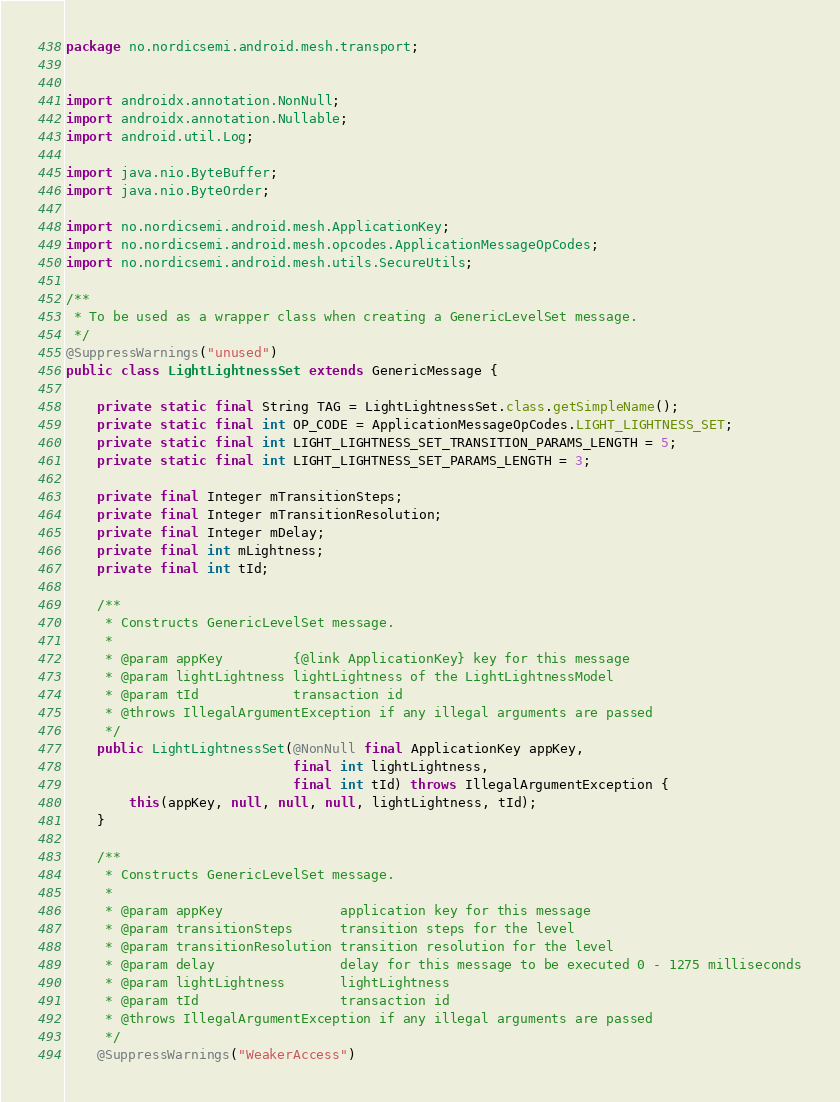<code> <loc_0><loc_0><loc_500><loc_500><_Java_>package no.nordicsemi.android.mesh.transport;


import androidx.annotation.NonNull;
import androidx.annotation.Nullable;
import android.util.Log;

import java.nio.ByteBuffer;
import java.nio.ByteOrder;

import no.nordicsemi.android.mesh.ApplicationKey;
import no.nordicsemi.android.mesh.opcodes.ApplicationMessageOpCodes;
import no.nordicsemi.android.mesh.utils.SecureUtils;

/**
 * To be used as a wrapper class when creating a GenericLevelSet message.
 */
@SuppressWarnings("unused")
public class LightLightnessSet extends GenericMessage {

    private static final String TAG = LightLightnessSet.class.getSimpleName();
    private static final int OP_CODE = ApplicationMessageOpCodes.LIGHT_LIGHTNESS_SET;
    private static final int LIGHT_LIGHTNESS_SET_TRANSITION_PARAMS_LENGTH = 5;
    private static final int LIGHT_LIGHTNESS_SET_PARAMS_LENGTH = 3;

    private final Integer mTransitionSteps;
    private final Integer mTransitionResolution;
    private final Integer mDelay;
    private final int mLightness;
    private final int tId;

    /**
     * Constructs GenericLevelSet message.
     *
     * @param appKey         {@link ApplicationKey} key for this message
     * @param lightLightness lightLightness of the LightLightnessModel
     * @param tId            transaction id
     * @throws IllegalArgumentException if any illegal arguments are passed
     */
    public LightLightnessSet(@NonNull final ApplicationKey appKey,
                             final int lightLightness,
                             final int tId) throws IllegalArgumentException {
        this(appKey, null, null, null, lightLightness, tId);
    }

    /**
     * Constructs GenericLevelSet message.
     *
     * @param appKey               application key for this message
     * @param transitionSteps      transition steps for the level
     * @param transitionResolution transition resolution for the level
     * @param delay                delay for this message to be executed 0 - 1275 milliseconds
     * @param lightLightness       lightLightness
     * @param tId                  transaction id
     * @throws IllegalArgumentException if any illegal arguments are passed
     */
    @SuppressWarnings("WeakerAccess")</code> 